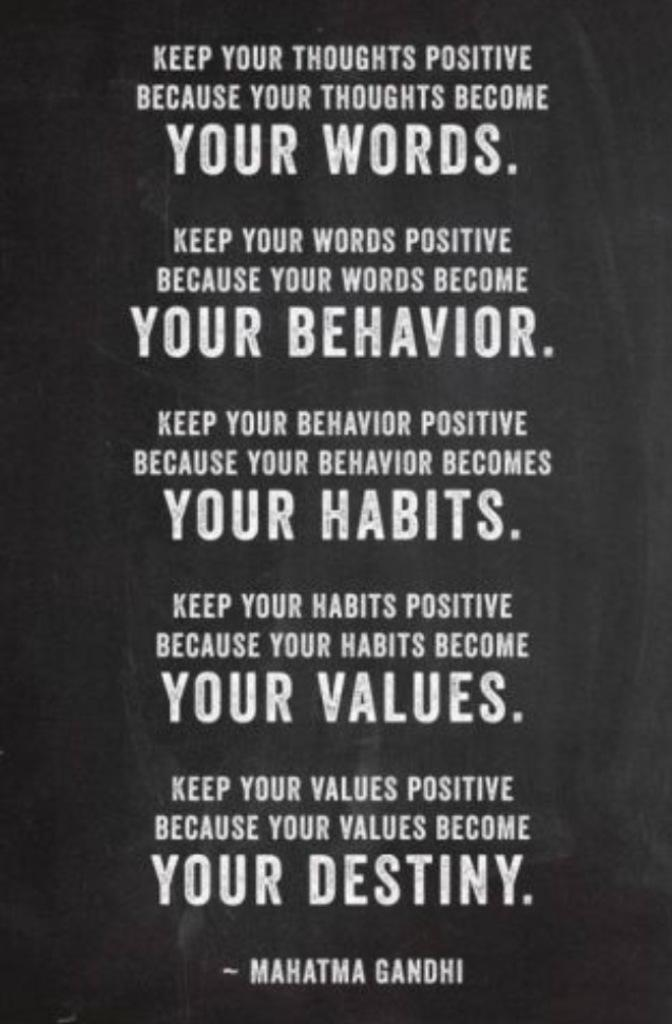<image>
Create a compact narrative representing the image presented. Mahatma Gandhi sayings in white text about your words, et cetera. 